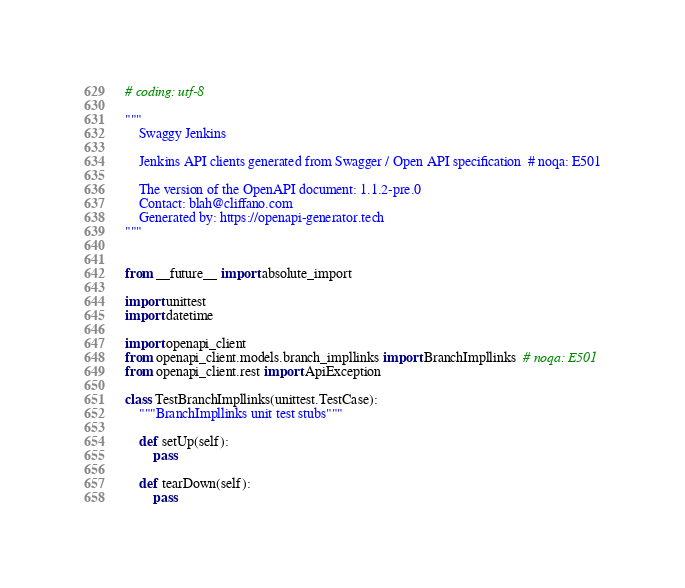<code> <loc_0><loc_0><loc_500><loc_500><_Python_># coding: utf-8

"""
    Swaggy Jenkins

    Jenkins API clients generated from Swagger / Open API specification  # noqa: E501

    The version of the OpenAPI document: 1.1.2-pre.0
    Contact: blah@cliffano.com
    Generated by: https://openapi-generator.tech
"""


from __future__ import absolute_import

import unittest
import datetime

import openapi_client
from openapi_client.models.branch_impllinks import BranchImpllinks  # noqa: E501
from openapi_client.rest import ApiException

class TestBranchImpllinks(unittest.TestCase):
    """BranchImpllinks unit test stubs"""

    def setUp(self):
        pass

    def tearDown(self):
        pass
</code> 